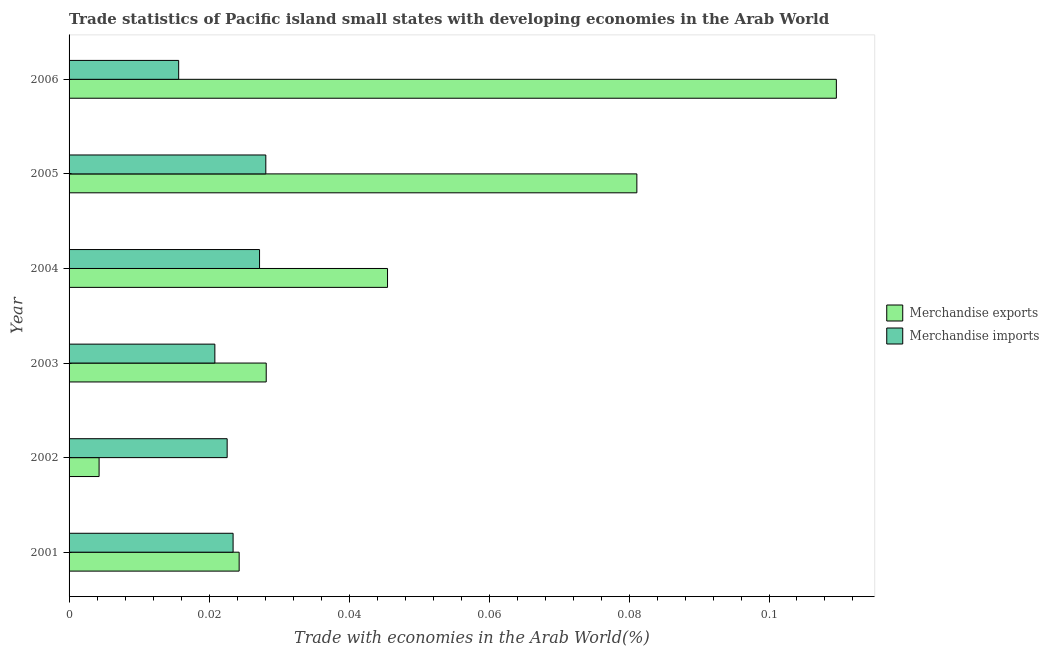How many different coloured bars are there?
Your answer should be compact. 2. Are the number of bars per tick equal to the number of legend labels?
Your answer should be very brief. Yes. In how many cases, is the number of bars for a given year not equal to the number of legend labels?
Provide a short and direct response. 0. What is the merchandise exports in 2004?
Provide a succinct answer. 0.05. Across all years, what is the maximum merchandise exports?
Provide a succinct answer. 0.11. Across all years, what is the minimum merchandise imports?
Offer a very short reply. 0.02. In which year was the merchandise imports maximum?
Your answer should be compact. 2005. In which year was the merchandise exports minimum?
Your answer should be very brief. 2002. What is the total merchandise exports in the graph?
Ensure brevity in your answer.  0.29. What is the difference between the merchandise exports in 2003 and that in 2006?
Make the answer very short. -0.08. What is the difference between the merchandise imports in 2006 and the merchandise exports in 2001?
Keep it short and to the point. -0.01. What is the average merchandise exports per year?
Offer a very short reply. 0.05. In the year 2005, what is the difference between the merchandise imports and merchandise exports?
Your answer should be very brief. -0.05. In how many years, is the merchandise imports greater than 0.012 %?
Your answer should be very brief. 6. What is the ratio of the merchandise exports in 2001 to that in 2003?
Keep it short and to the point. 0.86. What is the difference between the highest and the second highest merchandise exports?
Offer a terse response. 0.03. What does the 1st bar from the top in 2002 represents?
Your answer should be very brief. Merchandise imports. How many bars are there?
Offer a very short reply. 12. Are all the bars in the graph horizontal?
Keep it short and to the point. Yes. How many years are there in the graph?
Make the answer very short. 6. Does the graph contain any zero values?
Ensure brevity in your answer.  No. Where does the legend appear in the graph?
Ensure brevity in your answer.  Center right. How many legend labels are there?
Make the answer very short. 2. What is the title of the graph?
Keep it short and to the point. Trade statistics of Pacific island small states with developing economies in the Arab World. Does "Export" appear as one of the legend labels in the graph?
Provide a succinct answer. No. What is the label or title of the X-axis?
Provide a succinct answer. Trade with economies in the Arab World(%). What is the Trade with economies in the Arab World(%) of Merchandise exports in 2001?
Make the answer very short. 0.02. What is the Trade with economies in the Arab World(%) of Merchandise imports in 2001?
Offer a very short reply. 0.02. What is the Trade with economies in the Arab World(%) of Merchandise exports in 2002?
Provide a short and direct response. 0. What is the Trade with economies in the Arab World(%) of Merchandise imports in 2002?
Your response must be concise. 0.02. What is the Trade with economies in the Arab World(%) of Merchandise exports in 2003?
Offer a terse response. 0.03. What is the Trade with economies in the Arab World(%) in Merchandise imports in 2003?
Offer a very short reply. 0.02. What is the Trade with economies in the Arab World(%) in Merchandise exports in 2004?
Your response must be concise. 0.05. What is the Trade with economies in the Arab World(%) of Merchandise imports in 2004?
Ensure brevity in your answer.  0.03. What is the Trade with economies in the Arab World(%) in Merchandise exports in 2005?
Your response must be concise. 0.08. What is the Trade with economies in the Arab World(%) of Merchandise imports in 2005?
Provide a short and direct response. 0.03. What is the Trade with economies in the Arab World(%) in Merchandise exports in 2006?
Give a very brief answer. 0.11. What is the Trade with economies in the Arab World(%) of Merchandise imports in 2006?
Provide a short and direct response. 0.02. Across all years, what is the maximum Trade with economies in the Arab World(%) in Merchandise exports?
Ensure brevity in your answer.  0.11. Across all years, what is the maximum Trade with economies in the Arab World(%) of Merchandise imports?
Provide a short and direct response. 0.03. Across all years, what is the minimum Trade with economies in the Arab World(%) of Merchandise exports?
Ensure brevity in your answer.  0. Across all years, what is the minimum Trade with economies in the Arab World(%) of Merchandise imports?
Provide a short and direct response. 0.02. What is the total Trade with economies in the Arab World(%) of Merchandise exports in the graph?
Give a very brief answer. 0.29. What is the total Trade with economies in the Arab World(%) in Merchandise imports in the graph?
Your answer should be compact. 0.14. What is the difference between the Trade with economies in the Arab World(%) of Merchandise exports in 2001 and that in 2002?
Provide a succinct answer. 0.02. What is the difference between the Trade with economies in the Arab World(%) of Merchandise imports in 2001 and that in 2002?
Your response must be concise. 0. What is the difference between the Trade with economies in the Arab World(%) of Merchandise exports in 2001 and that in 2003?
Your response must be concise. -0. What is the difference between the Trade with economies in the Arab World(%) of Merchandise imports in 2001 and that in 2003?
Your response must be concise. 0. What is the difference between the Trade with economies in the Arab World(%) of Merchandise exports in 2001 and that in 2004?
Offer a terse response. -0.02. What is the difference between the Trade with economies in the Arab World(%) in Merchandise imports in 2001 and that in 2004?
Provide a succinct answer. -0. What is the difference between the Trade with economies in the Arab World(%) in Merchandise exports in 2001 and that in 2005?
Offer a very short reply. -0.06. What is the difference between the Trade with economies in the Arab World(%) of Merchandise imports in 2001 and that in 2005?
Your response must be concise. -0. What is the difference between the Trade with economies in the Arab World(%) in Merchandise exports in 2001 and that in 2006?
Offer a very short reply. -0.09. What is the difference between the Trade with economies in the Arab World(%) in Merchandise imports in 2001 and that in 2006?
Provide a succinct answer. 0.01. What is the difference between the Trade with economies in the Arab World(%) of Merchandise exports in 2002 and that in 2003?
Keep it short and to the point. -0.02. What is the difference between the Trade with economies in the Arab World(%) of Merchandise imports in 2002 and that in 2003?
Offer a terse response. 0. What is the difference between the Trade with economies in the Arab World(%) of Merchandise exports in 2002 and that in 2004?
Your response must be concise. -0.04. What is the difference between the Trade with economies in the Arab World(%) in Merchandise imports in 2002 and that in 2004?
Your answer should be compact. -0. What is the difference between the Trade with economies in the Arab World(%) in Merchandise exports in 2002 and that in 2005?
Keep it short and to the point. -0.08. What is the difference between the Trade with economies in the Arab World(%) of Merchandise imports in 2002 and that in 2005?
Offer a terse response. -0.01. What is the difference between the Trade with economies in the Arab World(%) in Merchandise exports in 2002 and that in 2006?
Provide a succinct answer. -0.11. What is the difference between the Trade with economies in the Arab World(%) in Merchandise imports in 2002 and that in 2006?
Your answer should be compact. 0.01. What is the difference between the Trade with economies in the Arab World(%) in Merchandise exports in 2003 and that in 2004?
Offer a very short reply. -0.02. What is the difference between the Trade with economies in the Arab World(%) of Merchandise imports in 2003 and that in 2004?
Offer a very short reply. -0.01. What is the difference between the Trade with economies in the Arab World(%) in Merchandise exports in 2003 and that in 2005?
Ensure brevity in your answer.  -0.05. What is the difference between the Trade with economies in the Arab World(%) of Merchandise imports in 2003 and that in 2005?
Give a very brief answer. -0.01. What is the difference between the Trade with economies in the Arab World(%) of Merchandise exports in 2003 and that in 2006?
Provide a short and direct response. -0.08. What is the difference between the Trade with economies in the Arab World(%) in Merchandise imports in 2003 and that in 2006?
Offer a very short reply. 0.01. What is the difference between the Trade with economies in the Arab World(%) of Merchandise exports in 2004 and that in 2005?
Your response must be concise. -0.04. What is the difference between the Trade with economies in the Arab World(%) in Merchandise imports in 2004 and that in 2005?
Your response must be concise. -0. What is the difference between the Trade with economies in the Arab World(%) in Merchandise exports in 2004 and that in 2006?
Make the answer very short. -0.06. What is the difference between the Trade with economies in the Arab World(%) in Merchandise imports in 2004 and that in 2006?
Provide a succinct answer. 0.01. What is the difference between the Trade with economies in the Arab World(%) of Merchandise exports in 2005 and that in 2006?
Make the answer very short. -0.03. What is the difference between the Trade with economies in the Arab World(%) of Merchandise imports in 2005 and that in 2006?
Make the answer very short. 0.01. What is the difference between the Trade with economies in the Arab World(%) of Merchandise exports in 2001 and the Trade with economies in the Arab World(%) of Merchandise imports in 2002?
Offer a terse response. 0. What is the difference between the Trade with economies in the Arab World(%) in Merchandise exports in 2001 and the Trade with economies in the Arab World(%) in Merchandise imports in 2003?
Your response must be concise. 0. What is the difference between the Trade with economies in the Arab World(%) of Merchandise exports in 2001 and the Trade with economies in the Arab World(%) of Merchandise imports in 2004?
Provide a succinct answer. -0. What is the difference between the Trade with economies in the Arab World(%) in Merchandise exports in 2001 and the Trade with economies in the Arab World(%) in Merchandise imports in 2005?
Offer a very short reply. -0. What is the difference between the Trade with economies in the Arab World(%) of Merchandise exports in 2001 and the Trade with economies in the Arab World(%) of Merchandise imports in 2006?
Give a very brief answer. 0.01. What is the difference between the Trade with economies in the Arab World(%) in Merchandise exports in 2002 and the Trade with economies in the Arab World(%) in Merchandise imports in 2003?
Offer a very short reply. -0.02. What is the difference between the Trade with economies in the Arab World(%) of Merchandise exports in 2002 and the Trade with economies in the Arab World(%) of Merchandise imports in 2004?
Your answer should be compact. -0.02. What is the difference between the Trade with economies in the Arab World(%) of Merchandise exports in 2002 and the Trade with economies in the Arab World(%) of Merchandise imports in 2005?
Your response must be concise. -0.02. What is the difference between the Trade with economies in the Arab World(%) of Merchandise exports in 2002 and the Trade with economies in the Arab World(%) of Merchandise imports in 2006?
Provide a short and direct response. -0.01. What is the difference between the Trade with economies in the Arab World(%) of Merchandise exports in 2003 and the Trade with economies in the Arab World(%) of Merchandise imports in 2005?
Your answer should be compact. 0. What is the difference between the Trade with economies in the Arab World(%) of Merchandise exports in 2003 and the Trade with economies in the Arab World(%) of Merchandise imports in 2006?
Offer a terse response. 0.01. What is the difference between the Trade with economies in the Arab World(%) of Merchandise exports in 2004 and the Trade with economies in the Arab World(%) of Merchandise imports in 2005?
Your response must be concise. 0.02. What is the difference between the Trade with economies in the Arab World(%) in Merchandise exports in 2004 and the Trade with economies in the Arab World(%) in Merchandise imports in 2006?
Ensure brevity in your answer.  0.03. What is the difference between the Trade with economies in the Arab World(%) in Merchandise exports in 2005 and the Trade with economies in the Arab World(%) in Merchandise imports in 2006?
Provide a short and direct response. 0.07. What is the average Trade with economies in the Arab World(%) in Merchandise exports per year?
Keep it short and to the point. 0.05. What is the average Trade with economies in the Arab World(%) of Merchandise imports per year?
Provide a succinct answer. 0.02. In the year 2001, what is the difference between the Trade with economies in the Arab World(%) of Merchandise exports and Trade with economies in the Arab World(%) of Merchandise imports?
Your answer should be very brief. 0. In the year 2002, what is the difference between the Trade with economies in the Arab World(%) of Merchandise exports and Trade with economies in the Arab World(%) of Merchandise imports?
Your response must be concise. -0.02. In the year 2003, what is the difference between the Trade with economies in the Arab World(%) in Merchandise exports and Trade with economies in the Arab World(%) in Merchandise imports?
Your answer should be compact. 0.01. In the year 2004, what is the difference between the Trade with economies in the Arab World(%) in Merchandise exports and Trade with economies in the Arab World(%) in Merchandise imports?
Provide a short and direct response. 0.02. In the year 2005, what is the difference between the Trade with economies in the Arab World(%) in Merchandise exports and Trade with economies in the Arab World(%) in Merchandise imports?
Provide a succinct answer. 0.05. In the year 2006, what is the difference between the Trade with economies in the Arab World(%) in Merchandise exports and Trade with economies in the Arab World(%) in Merchandise imports?
Provide a short and direct response. 0.09. What is the ratio of the Trade with economies in the Arab World(%) of Merchandise exports in 2001 to that in 2002?
Your answer should be compact. 5.66. What is the ratio of the Trade with economies in the Arab World(%) in Merchandise imports in 2001 to that in 2002?
Provide a succinct answer. 1.04. What is the ratio of the Trade with economies in the Arab World(%) in Merchandise exports in 2001 to that in 2003?
Ensure brevity in your answer.  0.86. What is the ratio of the Trade with economies in the Arab World(%) in Merchandise exports in 2001 to that in 2004?
Keep it short and to the point. 0.53. What is the ratio of the Trade with economies in the Arab World(%) of Merchandise imports in 2001 to that in 2004?
Offer a terse response. 0.86. What is the ratio of the Trade with economies in the Arab World(%) in Merchandise exports in 2001 to that in 2005?
Your answer should be compact. 0.3. What is the ratio of the Trade with economies in the Arab World(%) in Merchandise imports in 2001 to that in 2005?
Give a very brief answer. 0.83. What is the ratio of the Trade with economies in the Arab World(%) of Merchandise exports in 2001 to that in 2006?
Make the answer very short. 0.22. What is the ratio of the Trade with economies in the Arab World(%) in Merchandise imports in 2001 to that in 2006?
Make the answer very short. 1.5. What is the ratio of the Trade with economies in the Arab World(%) in Merchandise exports in 2002 to that in 2003?
Provide a short and direct response. 0.15. What is the ratio of the Trade with economies in the Arab World(%) of Merchandise imports in 2002 to that in 2003?
Make the answer very short. 1.08. What is the ratio of the Trade with economies in the Arab World(%) in Merchandise exports in 2002 to that in 2004?
Your response must be concise. 0.09. What is the ratio of the Trade with economies in the Arab World(%) in Merchandise imports in 2002 to that in 2004?
Give a very brief answer. 0.83. What is the ratio of the Trade with economies in the Arab World(%) of Merchandise exports in 2002 to that in 2005?
Make the answer very short. 0.05. What is the ratio of the Trade with economies in the Arab World(%) of Merchandise imports in 2002 to that in 2005?
Keep it short and to the point. 0.8. What is the ratio of the Trade with economies in the Arab World(%) in Merchandise exports in 2002 to that in 2006?
Offer a very short reply. 0.04. What is the ratio of the Trade with economies in the Arab World(%) in Merchandise imports in 2002 to that in 2006?
Your answer should be very brief. 1.44. What is the ratio of the Trade with economies in the Arab World(%) of Merchandise exports in 2003 to that in 2004?
Offer a terse response. 0.62. What is the ratio of the Trade with economies in the Arab World(%) of Merchandise imports in 2003 to that in 2004?
Your response must be concise. 0.77. What is the ratio of the Trade with economies in the Arab World(%) in Merchandise exports in 2003 to that in 2005?
Make the answer very short. 0.35. What is the ratio of the Trade with economies in the Arab World(%) of Merchandise imports in 2003 to that in 2005?
Make the answer very short. 0.74. What is the ratio of the Trade with economies in the Arab World(%) of Merchandise exports in 2003 to that in 2006?
Provide a short and direct response. 0.26. What is the ratio of the Trade with economies in the Arab World(%) of Merchandise imports in 2003 to that in 2006?
Offer a very short reply. 1.33. What is the ratio of the Trade with economies in the Arab World(%) in Merchandise exports in 2004 to that in 2005?
Give a very brief answer. 0.56. What is the ratio of the Trade with economies in the Arab World(%) in Merchandise imports in 2004 to that in 2005?
Your response must be concise. 0.97. What is the ratio of the Trade with economies in the Arab World(%) in Merchandise exports in 2004 to that in 2006?
Offer a terse response. 0.41. What is the ratio of the Trade with economies in the Arab World(%) in Merchandise imports in 2004 to that in 2006?
Provide a succinct answer. 1.74. What is the ratio of the Trade with economies in the Arab World(%) of Merchandise exports in 2005 to that in 2006?
Ensure brevity in your answer.  0.74. What is the ratio of the Trade with economies in the Arab World(%) of Merchandise imports in 2005 to that in 2006?
Give a very brief answer. 1.8. What is the difference between the highest and the second highest Trade with economies in the Arab World(%) in Merchandise exports?
Your answer should be compact. 0.03. What is the difference between the highest and the second highest Trade with economies in the Arab World(%) of Merchandise imports?
Your answer should be compact. 0. What is the difference between the highest and the lowest Trade with economies in the Arab World(%) in Merchandise exports?
Your answer should be compact. 0.11. What is the difference between the highest and the lowest Trade with economies in the Arab World(%) in Merchandise imports?
Keep it short and to the point. 0.01. 